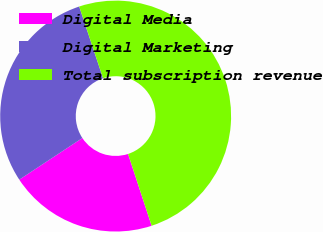<chart> <loc_0><loc_0><loc_500><loc_500><pie_chart><fcel>Digital Media<fcel>Digital Marketing<fcel>Total subscription revenue<nl><fcel>20.76%<fcel>29.17%<fcel>50.06%<nl></chart> 